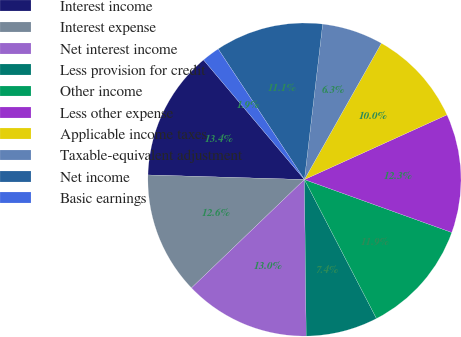Convert chart. <chart><loc_0><loc_0><loc_500><loc_500><pie_chart><fcel>Interest income<fcel>Interest expense<fcel>Net interest income<fcel>Less provision for credit<fcel>Other income<fcel>Less other expense<fcel>Applicable income taxes<fcel>Taxable-equivalent adjustment<fcel>Net income<fcel>Basic earnings<nl><fcel>13.38%<fcel>12.64%<fcel>13.01%<fcel>7.43%<fcel>11.9%<fcel>12.27%<fcel>10.04%<fcel>6.32%<fcel>11.15%<fcel>1.86%<nl></chart> 